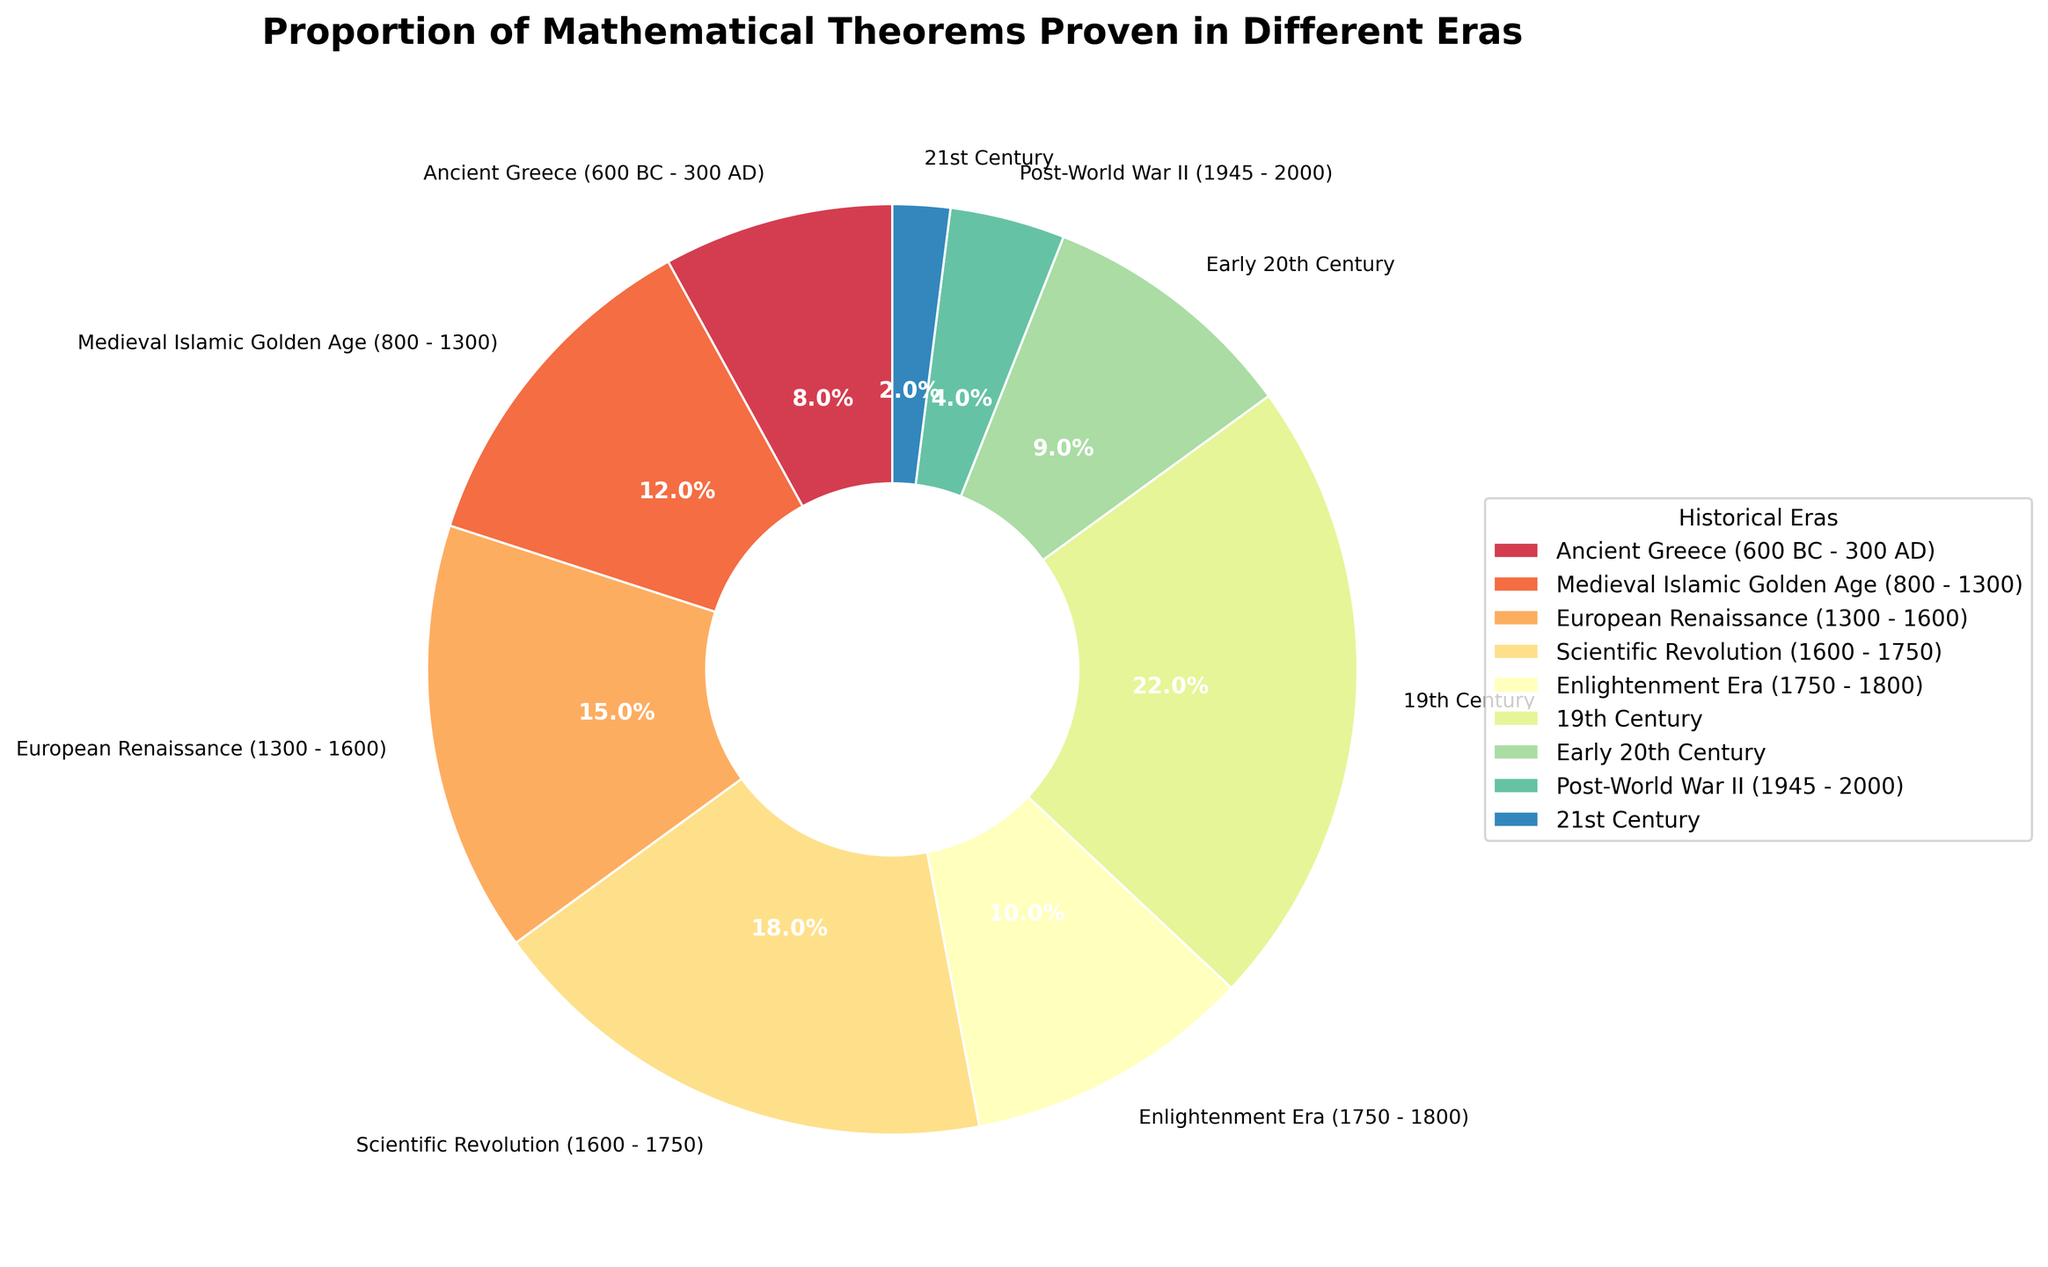Which era has the highest proportion of mathematical theorems proven? By looking at the pie chart, we can see which segment represents the largest percentage of the total theorems proven. The 19th Century segment is the largest.
Answer: 19th Century What is the combined proportion of mathematical theorems proven in the Scientific Revolution and the Enlightenment Era? The percentage of theorems proven in the Scientific Revolution is 18%, and in the Enlightenment Era is 10%. Adding these two percentages gives us 18 + 10 = 28%.
Answer: 28% Which era has a higher proportion of mathematical theorems proven, the European Renaissance or the Early 20th Century? By comparing the proportions, the European Renaissance has 15%, while the Early 20th Century has 9%. Therefore, the European Renaissance has a higher proportion.
Answer: European Renaissance How does the proportion of mathematical theorems proven in the Ancient Greece era compare to the 21st Century? By looking at the chart, we see the Ancient Greece era has 8%, while the 21st Century has 2%. Therefore, the Ancient Greece era has a significantly higher proportion.
Answer: Ancient Greece What is the total proportion of mathematical theorems proven after World War II, including the 21st Century? The proportion for the Post-World War II era is 4%, and for the 21st Century, it is 2%. Adding these we get 4 + 2 = 6%.
Answer: 6% Which two eras have a combined proportion closest to 20%? Examining the pie chart, the Enlightenment Era (10%) and the Early 20th Century (9%) add up to almost 20%, totaling 19%.
Answer: Enlightenment Era and Early 20th Century Considering the Scientific Revolution and the 19th Century, which era's wedge has a lighter color shade? By visually comparing the colors used in the pie chart, the 19th Century has a lighter shade compared to the Scientific Revolution.
Answer: 19th Century Of the eras covered, which one has the smallest contribution to the proportion of mathematical theorems proven? The pie chart shows all segments and their proportions. The smallest segment, representing the 21st Century, has the least contribution at 2%.
Answer: 21st Century What is the percentage point difference between the Medieval Islamic Golden Age and Post-World War II periods? The Medieval Islamic Golden Age has 12%, and Post-World War II has 4%. The difference is 12 - 4 = 8 percentage points.
Answer: 8 percentage points 